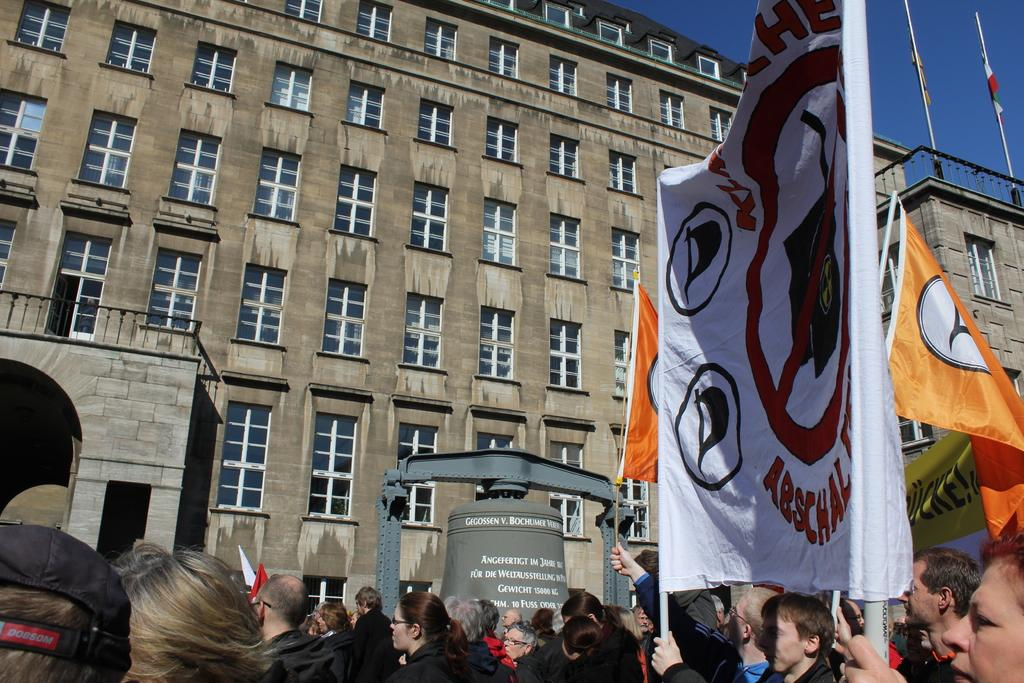What is the main structure in the image? There is a building in the image. What is happening in front of the building? There is a crowd in front of the building. Can you describe any specific actions or objects being held by someone in the image? There is a person holding a banner in the image. What else can be seen in the top right of the image? There are two poles visible in the top right of the image. What is visible in the background of the image? The sky is visible in the image. How many cats can be seen playing with the banner in the image? There are no cats present in the image, so no such activity can be observed. 